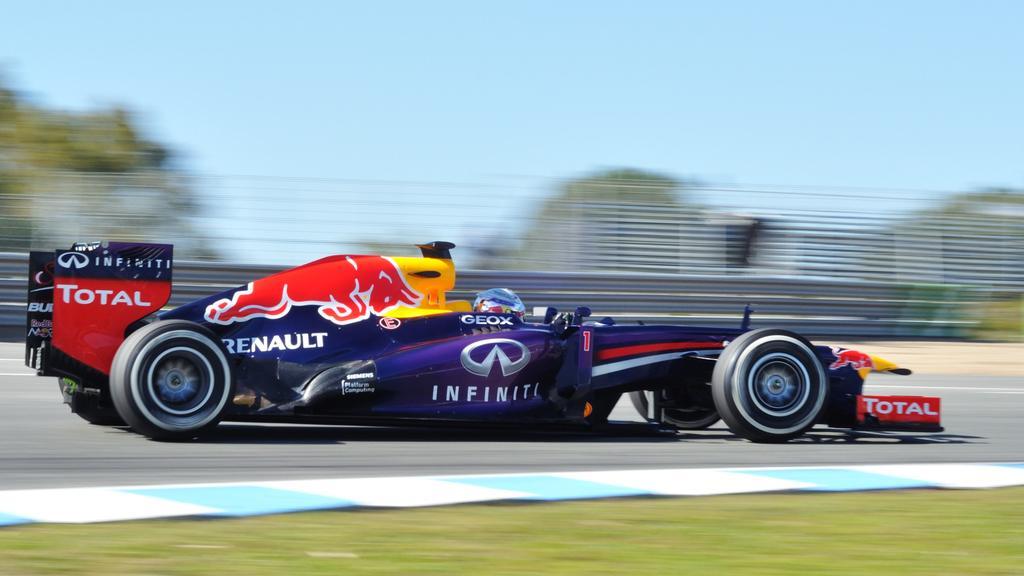Describe this image in one or two sentences. In the center of the image we can see a racing car on the road. In the background there are trees and sky. 